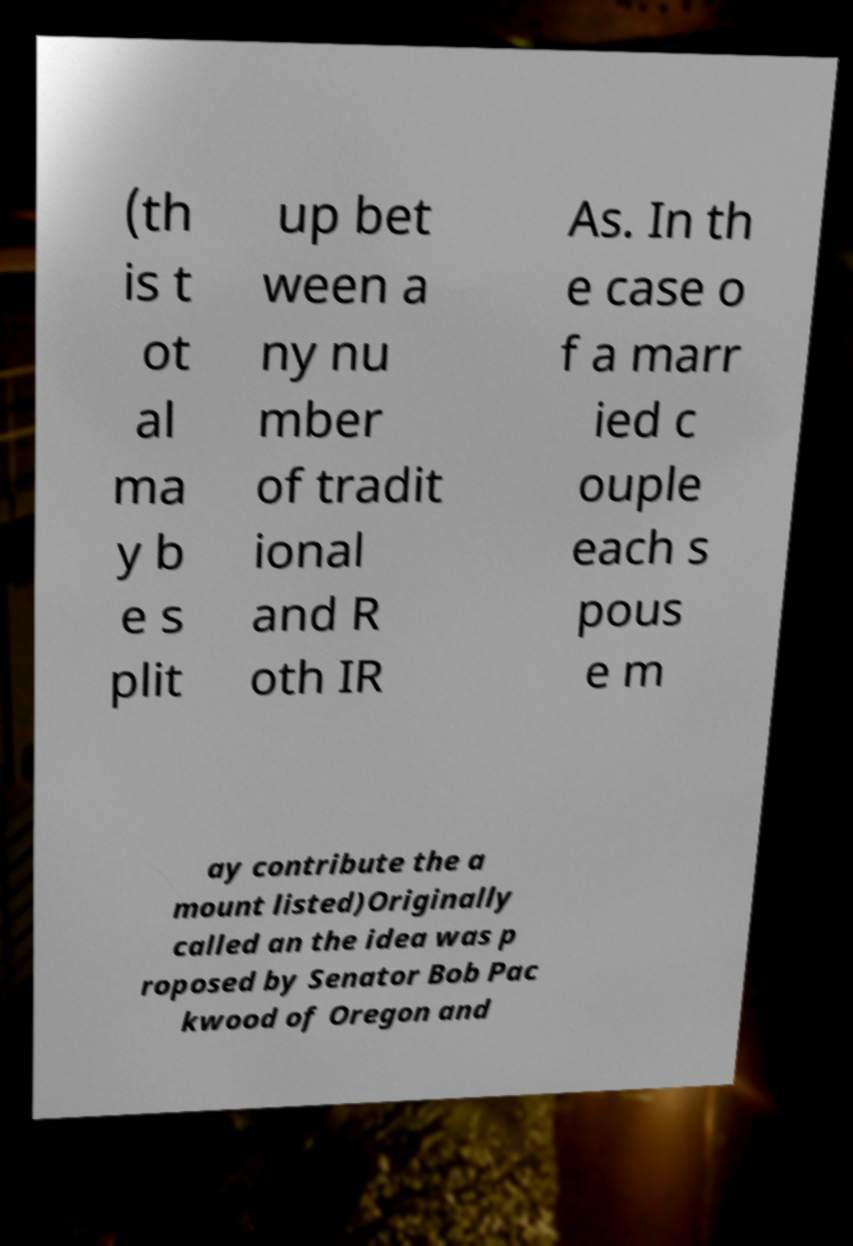Please read and relay the text visible in this image. What does it say? (th is t ot al ma y b e s plit up bet ween a ny nu mber of tradit ional and R oth IR As. In th e case o f a marr ied c ouple each s pous e m ay contribute the a mount listed)Originally called an the idea was p roposed by Senator Bob Pac kwood of Oregon and 